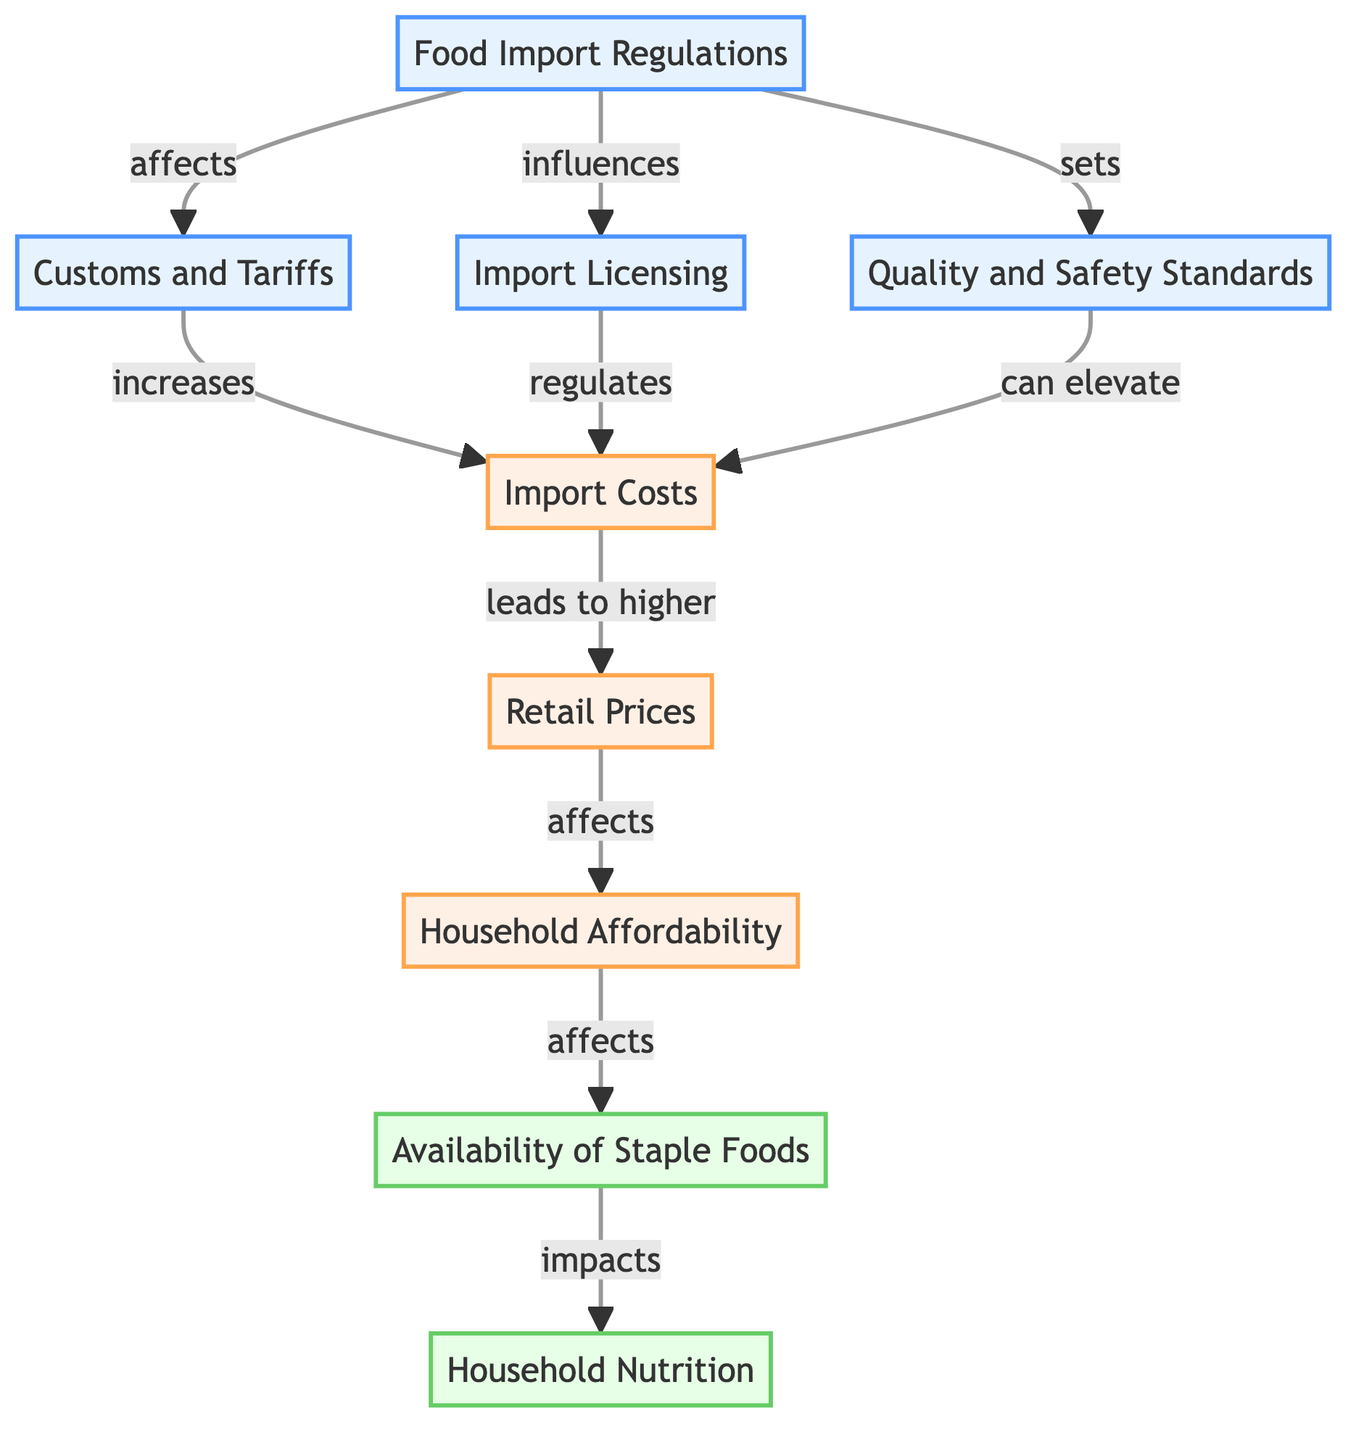What is the primary node in this diagram? The primary node is "Food Import Regulations," which influences various other elements in the food supply chain in Senegal.
Answer: Food Import Regulations How many impact nodes are there? The diagram contains three impact nodes: "Import Costs," "Retail Prices," and "Household Affordability." Counting these nodes gives a total of three.
Answer: 3 Which node is directly influenced by "Quality and Safety Standards"? "Quality and Safety Standards" directly influences "Import Costs," as indicated by a connection in the diagram.
Answer: Import Costs What effect do "Customs and Tariffs" have on "Import Costs"? "Customs and Tariffs" are shown to increase "Import Costs" in the diagram, which denotes a clear relationship.
Answer: increases How do "Household Affordability" and "Availability of Staple Foods" relate? "Household Affordability" affects "Availability of Staple Foods" in the diagram, suggesting that affordability directly impacts what households can access.
Answer: affects What is the final outcome impacted by the "Availability of Staple Foods"? The final outcome that is impacted by the "Availability of Staple Foods" is "Household Nutrition," showing a connection from food availability to nutritional status.
Answer: Household Nutrition Describe the flow from "Food Import Regulations" to "Retail Prices." The flow starts at "Food Import Regulations," which affects "Customs and Tariffs" and ultimately leads to higher "Import Costs," resulting in higher "Retail Prices." Thus, there are multiple points in this flow that connect them all together.
Answer: affects How does "Import Licensing" relate to "Import Costs"? "Import Licensing" regulates "Import Costs," indicating that licensing requirements can influence the expenses associated with importing food.
Answer: regulates Which node has the most connections to other nodes? "Food Import Regulations" has the most connections as it influences "Customs and Tariffs," "Import Licensing," and "Quality and Safety Standards," showing its central role in the diagram.
Answer: Food Import Regulations 